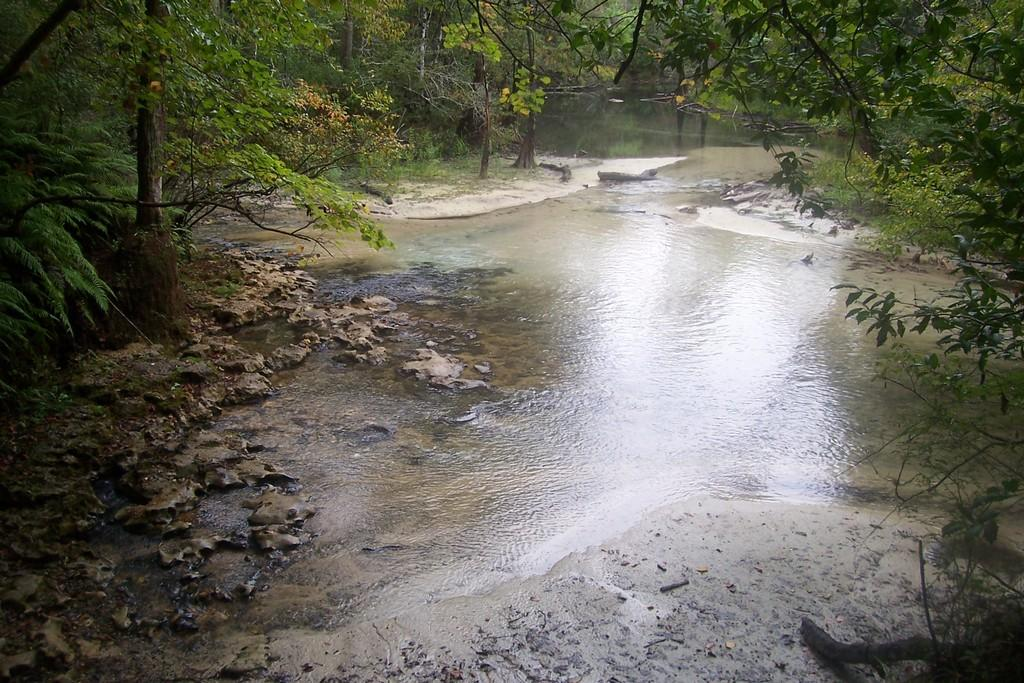What type of natural environment is depicted in the image? The image features trees, water, and rocks, which suggests a natural setting such as a forest or riverbank. Can you describe the water in the image? The water is visible at the bottom of the image. What other elements can be seen in the image besides trees and water? There are rocks in the image. How many beds are visible in the image? There are no beds present in the image; it features a natural setting with trees, water, and rocks. What type of bait is being used by the fish in the image? There are no fish or bait present in the image. 